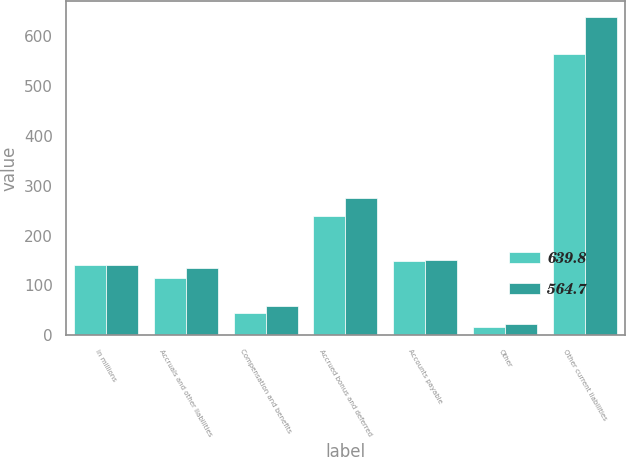Convert chart to OTSL. <chart><loc_0><loc_0><loc_500><loc_500><stacked_bar_chart><ecel><fcel>in millions<fcel>Accruals and other liabilities<fcel>Compensation and benefits<fcel>Accrued bonus and deferred<fcel>Accounts payable<fcel>Other<fcel>Other current liabilities<nl><fcel>639.8<fcel>141.05<fcel>115.2<fcel>45.1<fcel>239.2<fcel>148.1<fcel>17.1<fcel>564.7<nl><fcel>564.7<fcel>141.05<fcel>134<fcel>59.1<fcel>275<fcel>150.2<fcel>21.5<fcel>639.8<nl></chart> 